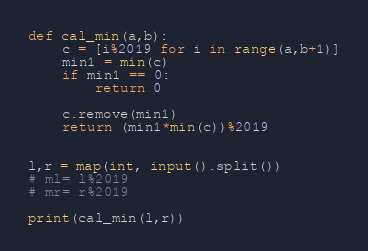Convert code to text. <code><loc_0><loc_0><loc_500><loc_500><_Python_>def cal_min(a,b):
    c = [i%2019 for i in range(a,b+1)]
    min1 = min(c)
    if min1 == 0:
        return 0
    
    c.remove(min1)
    return (min1*min(c))%2019


l,r = map(int, input().split())
# ml= l%2019
# mr= r%2019

print(cal_min(l,r))</code> 